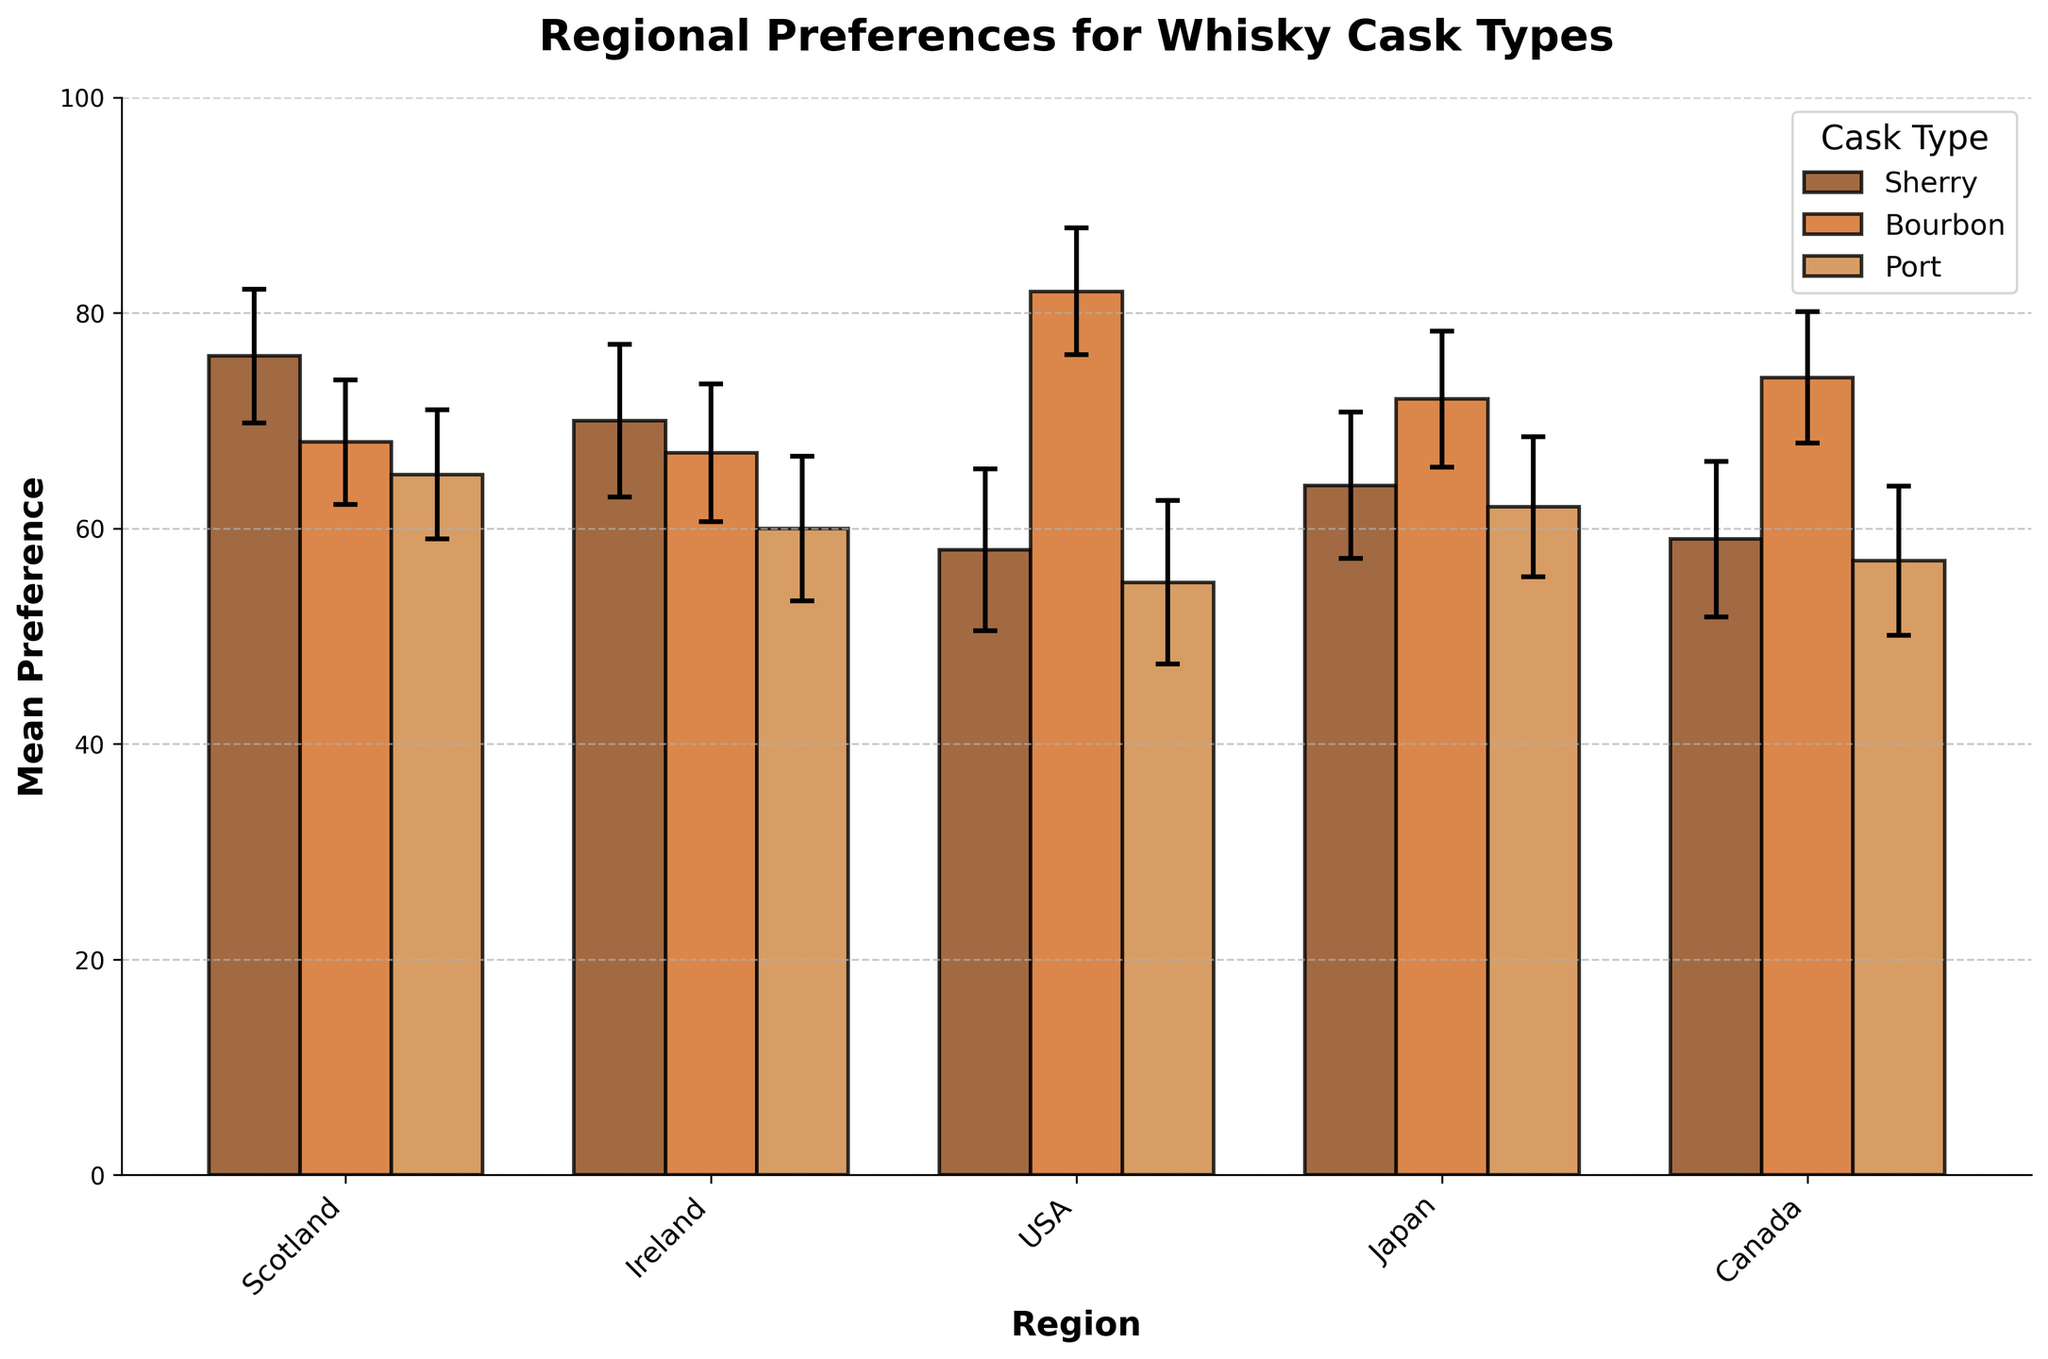Which region shows the highest mean preference for Bourbon cask type? By visually inspecting the bars representing Bourbon cask type across all regions, you can identify which one reaches the highest point. The USA has the highest bar for Bourbon cask type.
Answer: USA Which cask type has the lowest mean preference in Scotland? Look at the bars corresponding to Scotland for each cask type and identify the shortest bar. The Port cask type is the lowest among the three.
Answer: Port What is the mean preference for Sherry cask type in Japan? Find the bar corresponding to Sherry in Japan and read the mean value. The mean preference is 64.
Answer: 64 How much higher is the mean preference for Bourbon compared to Sherry in the USA? Identify the heights of the Bourbon and Sherry bars in the USA and subtract the Sherry preference from the Bourbon preference (82 - 58).
Answer: 24 What are the error bars for Sherry cask type in Scotland? Look at the size of the error bars for the Sherry cask type in Scotland. The error bars represent a standard deviation of 6.2.
Answer: ±6.2 Which cask type shows the most variability in preference in Canada? Compare the standard deviations (represented by the error bars) for each cask type in Canada. The Sherry cask type has the largest standard deviation, indicating the most variability.
Answer: Sherry What is the range of preference values (considering error bars) for Port cask type in Japan? The range is determined by adding and subtracting the standard deviation from the mean preference value. For Port in Japan, the mean is 62 and the standard deviation is 6.5. The range is 62 ± 6.5 (55.5 to 68.5).
Answer: 55.5 to 68.5 What is the average mean preference for all cask types in Ireland? Calculate the average of mean preferences for Sherry, Bourbon, and Port in Ireland (70 + 67 + 60) / 3. For three values, it is (197 / 3).
Answer: 65.67 Which region shows the most uniform preference across all cask types? Compare the lengths of the bars in each region. The region with bars closest in height across all cask types is Ireland.
Answer: Ireland 